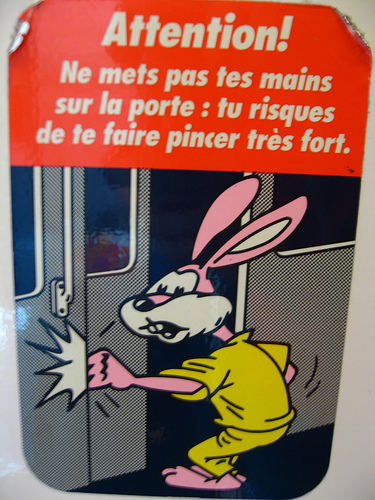<image>
Can you confirm if the rightside is in front of the leftside? No. The rightside is not in front of the leftside. The spatial positioning shows a different relationship between these objects. 